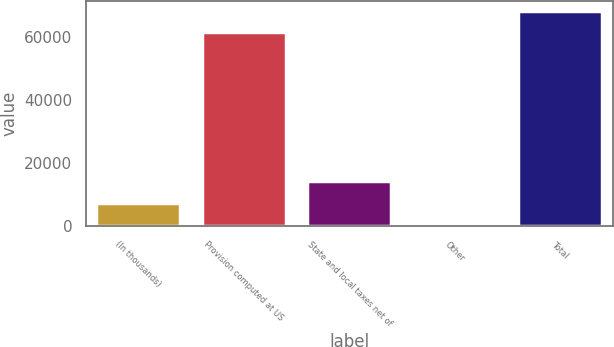<chart> <loc_0><loc_0><loc_500><loc_500><bar_chart><fcel>(In thousands)<fcel>Provision computed at US<fcel>State and local taxes net of<fcel>Other<fcel>Total<nl><fcel>7537.3<fcel>61402<fcel>14245.6<fcel>829<fcel>68110.3<nl></chart> 